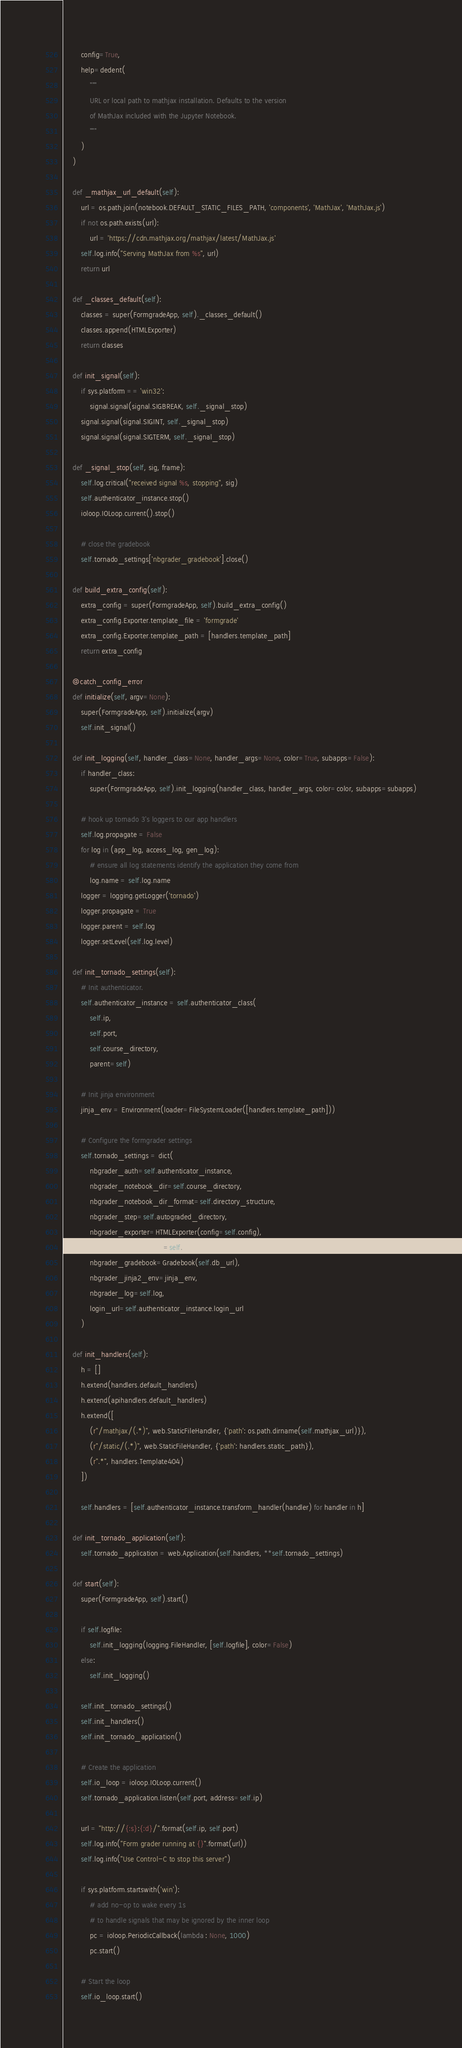Convert code to text. <code><loc_0><loc_0><loc_500><loc_500><_Python_>        config=True,
        help=dedent(
            """
            URL or local path to mathjax installation. Defaults to the version
            of MathJax included with the Jupyter Notebook.
            """
        )
    )

    def _mathjax_url_default(self):
        url = os.path.join(notebook.DEFAULT_STATIC_FILES_PATH, 'components', 'MathJax', 'MathJax.js')
        if not os.path.exists(url):
            url = 'https://cdn.mathjax.org/mathjax/latest/MathJax.js'
        self.log.info("Serving MathJax from %s", url)
        return url

    def _classes_default(self):
        classes = super(FormgradeApp, self)._classes_default()
        classes.append(HTMLExporter)
        return classes

    def init_signal(self):
        if sys.platform == 'win32':
            signal.signal(signal.SIGBREAK, self._signal_stop)
        signal.signal(signal.SIGINT, self._signal_stop)
        signal.signal(signal.SIGTERM, self._signal_stop)

    def _signal_stop(self, sig, frame):
        self.log.critical("received signal %s, stopping", sig)
        self.authenticator_instance.stop()
        ioloop.IOLoop.current().stop()

        # close the gradebook
        self.tornado_settings['nbgrader_gradebook'].close()

    def build_extra_config(self):
        extra_config = super(FormgradeApp, self).build_extra_config()
        extra_config.Exporter.template_file = 'formgrade'
        extra_config.Exporter.template_path = [handlers.template_path]
        return extra_config

    @catch_config_error
    def initialize(self, argv=None):
        super(FormgradeApp, self).initialize(argv)
        self.init_signal()

    def init_logging(self, handler_class=None, handler_args=None, color=True, subapps=False):
        if handler_class:
            super(FormgradeApp, self).init_logging(handler_class, handler_args, color=color, subapps=subapps)

        # hook up tornado 3's loggers to our app handlers
        self.log.propagate = False
        for log in (app_log, access_log, gen_log):
            # ensure all log statements identify the application they come from
            log.name = self.log.name
        logger = logging.getLogger('tornado')
        logger.propagate = True
        logger.parent = self.log
        logger.setLevel(self.log.level)

    def init_tornado_settings(self):
        # Init authenticator.
        self.authenticator_instance = self.authenticator_class(
            self.ip,
            self.port,
            self.course_directory,
            parent=self)

        # Init jinja environment
        jinja_env = Environment(loader=FileSystemLoader([handlers.template_path]))

        # Configure the formgrader settings
        self.tornado_settings = dict(
            nbgrader_auth=self.authenticator_instance,
            nbgrader_notebook_dir=self.course_directory,
            nbgrader_notebook_dir_format=self.directory_structure,
            nbgrader_step=self.autograded_directory,
            nbgrader_exporter=HTMLExporter(config=self.config),
            nbgrader_mathjax_url=self.mathjax_url,
            nbgrader_gradebook=Gradebook(self.db_url),
            nbgrader_jinja2_env=jinja_env,
            nbgrader_log=self.log,
            login_url=self.authenticator_instance.login_url
        )

    def init_handlers(self):
        h = []
        h.extend(handlers.default_handlers)
        h.extend(apihandlers.default_handlers)
        h.extend([
            (r"/mathjax/(.*)", web.StaticFileHandler, {'path': os.path.dirname(self.mathjax_url)}),
            (r"/static/(.*)", web.StaticFileHandler, {'path': handlers.static_path}),
            (r".*", handlers.Template404)
        ])

        self.handlers = [self.authenticator_instance.transform_handler(handler) for handler in h]

    def init_tornado_application(self):
        self.tornado_application = web.Application(self.handlers, **self.tornado_settings)

    def start(self):
        super(FormgradeApp, self).start()

        if self.logfile:
            self.init_logging(logging.FileHandler, [self.logfile], color=False)
        else:
            self.init_logging()

        self.init_tornado_settings()
        self.init_handlers()
        self.init_tornado_application()

        # Create the application
        self.io_loop = ioloop.IOLoop.current()
        self.tornado_application.listen(self.port, address=self.ip)

        url = "http://{:s}:{:d}/".format(self.ip, self.port)
        self.log.info("Form grader running at {}".format(url))
        self.log.info("Use Control-C to stop this server")

        if sys.platform.startswith('win'):
            # add no-op to wake every 1s
            # to handle signals that may be ignored by the inner loop
            pc = ioloop.PeriodicCallback(lambda : None, 1000)
            pc.start()

        # Start the loop
        self.io_loop.start()
</code> 